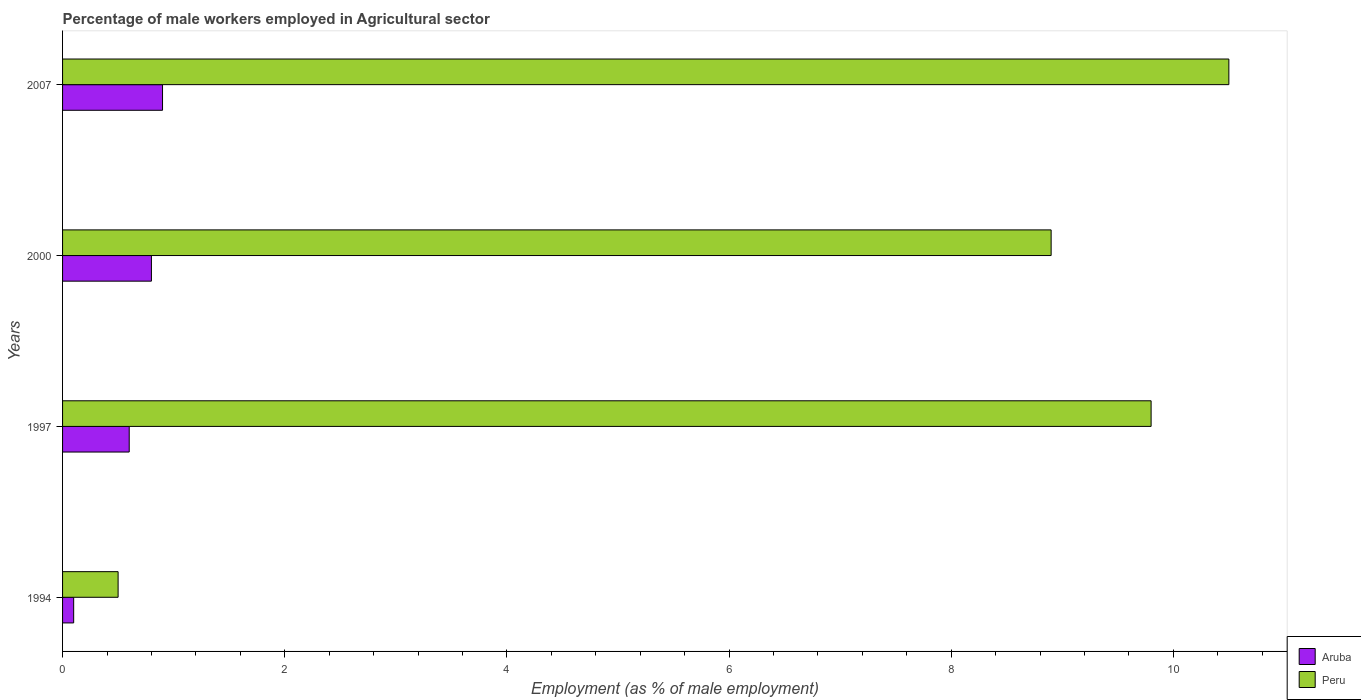Are the number of bars on each tick of the Y-axis equal?
Provide a short and direct response. Yes. What is the label of the 4th group of bars from the top?
Your answer should be very brief. 1994. What is the percentage of male workers employed in Agricultural sector in Aruba in 1997?
Your response must be concise. 0.6. Across all years, what is the minimum percentage of male workers employed in Agricultural sector in Peru?
Ensure brevity in your answer.  0.5. In which year was the percentage of male workers employed in Agricultural sector in Peru maximum?
Make the answer very short. 2007. What is the total percentage of male workers employed in Agricultural sector in Aruba in the graph?
Offer a very short reply. 2.4. What is the difference between the percentage of male workers employed in Agricultural sector in Aruba in 2007 and the percentage of male workers employed in Agricultural sector in Peru in 1997?
Offer a terse response. -8.9. What is the average percentage of male workers employed in Agricultural sector in Aruba per year?
Keep it short and to the point. 0.6. In the year 1997, what is the difference between the percentage of male workers employed in Agricultural sector in Peru and percentage of male workers employed in Agricultural sector in Aruba?
Offer a terse response. 9.2. What is the ratio of the percentage of male workers employed in Agricultural sector in Peru in 1994 to that in 2000?
Ensure brevity in your answer.  0.06. Is the difference between the percentage of male workers employed in Agricultural sector in Peru in 1994 and 2000 greater than the difference between the percentage of male workers employed in Agricultural sector in Aruba in 1994 and 2000?
Your response must be concise. No. What is the difference between the highest and the second highest percentage of male workers employed in Agricultural sector in Peru?
Provide a short and direct response. 0.7. In how many years, is the percentage of male workers employed in Agricultural sector in Peru greater than the average percentage of male workers employed in Agricultural sector in Peru taken over all years?
Your answer should be compact. 3. Is the sum of the percentage of male workers employed in Agricultural sector in Aruba in 1994 and 2007 greater than the maximum percentage of male workers employed in Agricultural sector in Peru across all years?
Provide a short and direct response. No. What does the 1st bar from the bottom in 1997 represents?
Provide a succinct answer. Aruba. How many bars are there?
Provide a short and direct response. 8. How many years are there in the graph?
Provide a short and direct response. 4. Does the graph contain grids?
Provide a succinct answer. No. How are the legend labels stacked?
Make the answer very short. Vertical. What is the title of the graph?
Offer a terse response. Percentage of male workers employed in Agricultural sector. Does "Algeria" appear as one of the legend labels in the graph?
Your answer should be very brief. No. What is the label or title of the X-axis?
Provide a succinct answer. Employment (as % of male employment). What is the label or title of the Y-axis?
Ensure brevity in your answer.  Years. What is the Employment (as % of male employment) of Aruba in 1994?
Offer a terse response. 0.1. What is the Employment (as % of male employment) of Aruba in 1997?
Ensure brevity in your answer.  0.6. What is the Employment (as % of male employment) in Peru in 1997?
Provide a succinct answer. 9.8. What is the Employment (as % of male employment) in Aruba in 2000?
Keep it short and to the point. 0.8. What is the Employment (as % of male employment) of Peru in 2000?
Give a very brief answer. 8.9. What is the Employment (as % of male employment) in Aruba in 2007?
Make the answer very short. 0.9. What is the Employment (as % of male employment) in Peru in 2007?
Your response must be concise. 10.5. Across all years, what is the maximum Employment (as % of male employment) of Aruba?
Ensure brevity in your answer.  0.9. Across all years, what is the maximum Employment (as % of male employment) of Peru?
Give a very brief answer. 10.5. Across all years, what is the minimum Employment (as % of male employment) in Aruba?
Provide a succinct answer. 0.1. Across all years, what is the minimum Employment (as % of male employment) in Peru?
Provide a succinct answer. 0.5. What is the total Employment (as % of male employment) of Peru in the graph?
Your answer should be very brief. 29.7. What is the difference between the Employment (as % of male employment) in Aruba in 1994 and that in 1997?
Offer a very short reply. -0.5. What is the difference between the Employment (as % of male employment) of Peru in 1994 and that in 1997?
Offer a very short reply. -9.3. What is the difference between the Employment (as % of male employment) of Aruba in 1994 and that in 2000?
Keep it short and to the point. -0.7. What is the difference between the Employment (as % of male employment) in Aruba in 1994 and that in 2007?
Your response must be concise. -0.8. What is the difference between the Employment (as % of male employment) in Peru in 1994 and that in 2007?
Provide a short and direct response. -10. What is the difference between the Employment (as % of male employment) in Aruba in 1994 and the Employment (as % of male employment) in Peru in 1997?
Your answer should be compact. -9.7. What is the difference between the Employment (as % of male employment) in Aruba in 1994 and the Employment (as % of male employment) in Peru in 2007?
Your answer should be very brief. -10.4. What is the difference between the Employment (as % of male employment) in Aruba in 1997 and the Employment (as % of male employment) in Peru in 2000?
Give a very brief answer. -8.3. What is the difference between the Employment (as % of male employment) of Aruba in 2000 and the Employment (as % of male employment) of Peru in 2007?
Provide a succinct answer. -9.7. What is the average Employment (as % of male employment) of Peru per year?
Provide a short and direct response. 7.42. In the year 1997, what is the difference between the Employment (as % of male employment) in Aruba and Employment (as % of male employment) in Peru?
Provide a succinct answer. -9.2. In the year 2000, what is the difference between the Employment (as % of male employment) in Aruba and Employment (as % of male employment) in Peru?
Ensure brevity in your answer.  -8.1. What is the ratio of the Employment (as % of male employment) in Peru in 1994 to that in 1997?
Your response must be concise. 0.05. What is the ratio of the Employment (as % of male employment) in Peru in 1994 to that in 2000?
Offer a very short reply. 0.06. What is the ratio of the Employment (as % of male employment) of Peru in 1994 to that in 2007?
Your answer should be very brief. 0.05. What is the ratio of the Employment (as % of male employment) in Peru in 1997 to that in 2000?
Your answer should be compact. 1.1. What is the ratio of the Employment (as % of male employment) in Aruba in 1997 to that in 2007?
Make the answer very short. 0.67. What is the ratio of the Employment (as % of male employment) of Aruba in 2000 to that in 2007?
Offer a terse response. 0.89. What is the ratio of the Employment (as % of male employment) in Peru in 2000 to that in 2007?
Make the answer very short. 0.85. What is the difference between the highest and the second highest Employment (as % of male employment) in Aruba?
Your answer should be compact. 0.1. What is the difference between the highest and the second highest Employment (as % of male employment) of Peru?
Offer a terse response. 0.7. What is the difference between the highest and the lowest Employment (as % of male employment) in Peru?
Give a very brief answer. 10. 